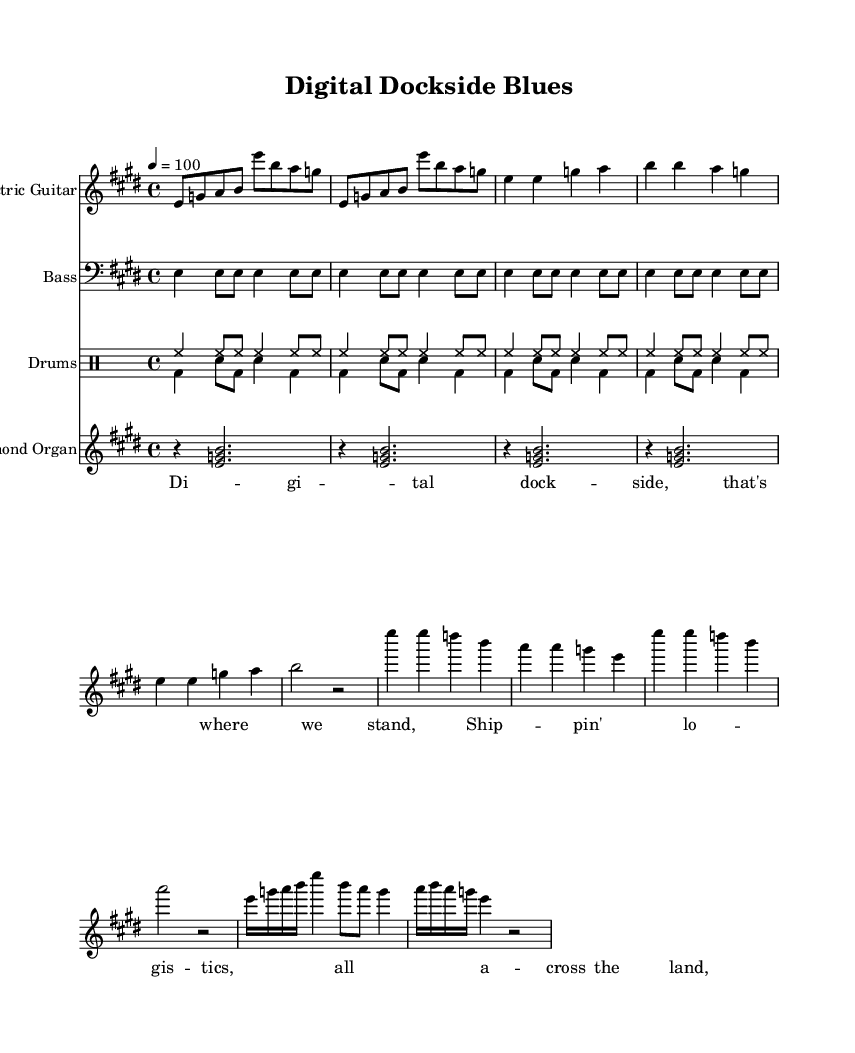What is the key signature of this music? The key signature indicates that there are four sharps, signifying E major. We can identify this by looking for the sharps in the key signature section, which clearly marks E major.
Answer: E major What is the time signature of this music? The time signature is found at the beginning of the score and shows a 4/4 time signature, which means there are four beats in each measure. This is common in blues music.
Answer: 4/4 What is the tempo marking for this piece? The tempo marking is noted at the start with "4 = 100," indicating that the quarter note is to be played at a speed of 100 beats per minute. This provides guidance on the speed at which the music should be played.
Answer: 100 How many repetitions of the main guitar riff occur in the electric guitar part? The electric guitar section has the main riff repeated twice, as indicated by the "repeat unfold 2" notation found earlier in the part. This tells us how many times to play that section.
Answer: 2 What is the function of the Hammond organ in this music? The Hammond organ adds harmonic support and depth by playing chords in a sustained manner. In this piece, it plays the chords once every four beats providing texture and fullness to the sound, which is characteristic of Electric Blues.
Answer: Harmonic support How does the drumming pattern contribute to the electric blues feel? The drum patterns include a regular hi-hat and bass drum rhythm, paired with snare hits that provide a driving forward momentum typical in blues music. They establish a steady groove, essential for dancing and rhythmic support in electric blues.
Answer: Driving rhythm 